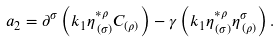Convert formula to latex. <formula><loc_0><loc_0><loc_500><loc_500>a _ { 2 } = \partial ^ { \sigma } \left ( k _ { 1 } \eta _ { \, ( \sigma ) } ^ { * \rho } C _ { ( \rho ) } \right ) - \gamma \left ( k _ { 1 } \eta _ { \, ( \sigma ) } ^ { * \rho } \eta _ { \, ( \rho ) } ^ { \sigma } \right ) .</formula> 